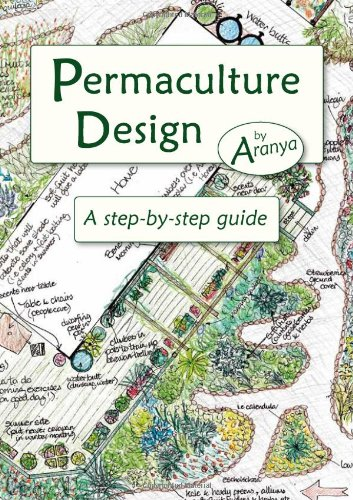What is the genre of this book? The genre of the book is 'Science & Math,' specifically focusing on the principles and practices of permaculture, which is an applied science. 